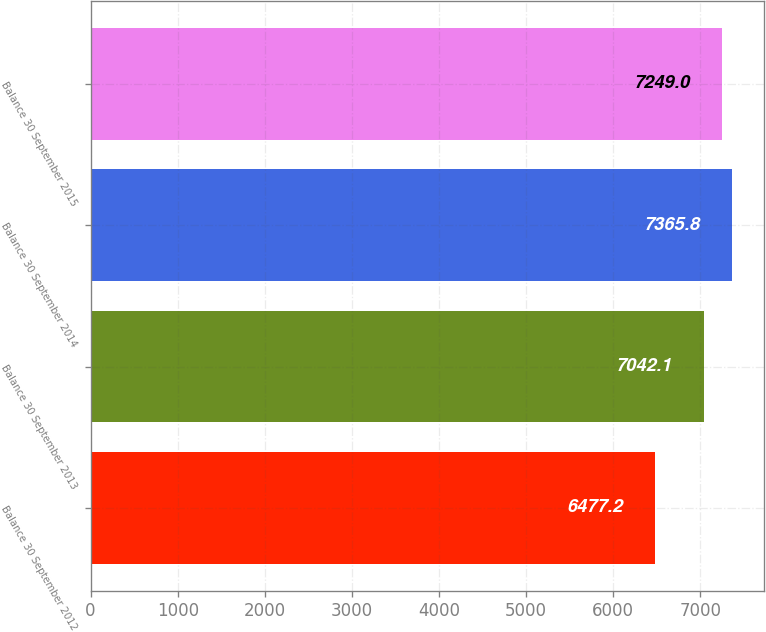Convert chart to OTSL. <chart><loc_0><loc_0><loc_500><loc_500><bar_chart><fcel>Balance 30 September 2012<fcel>Balance 30 September 2013<fcel>Balance 30 September 2014<fcel>Balance 30 September 2015<nl><fcel>6477.2<fcel>7042.1<fcel>7365.8<fcel>7249<nl></chart> 